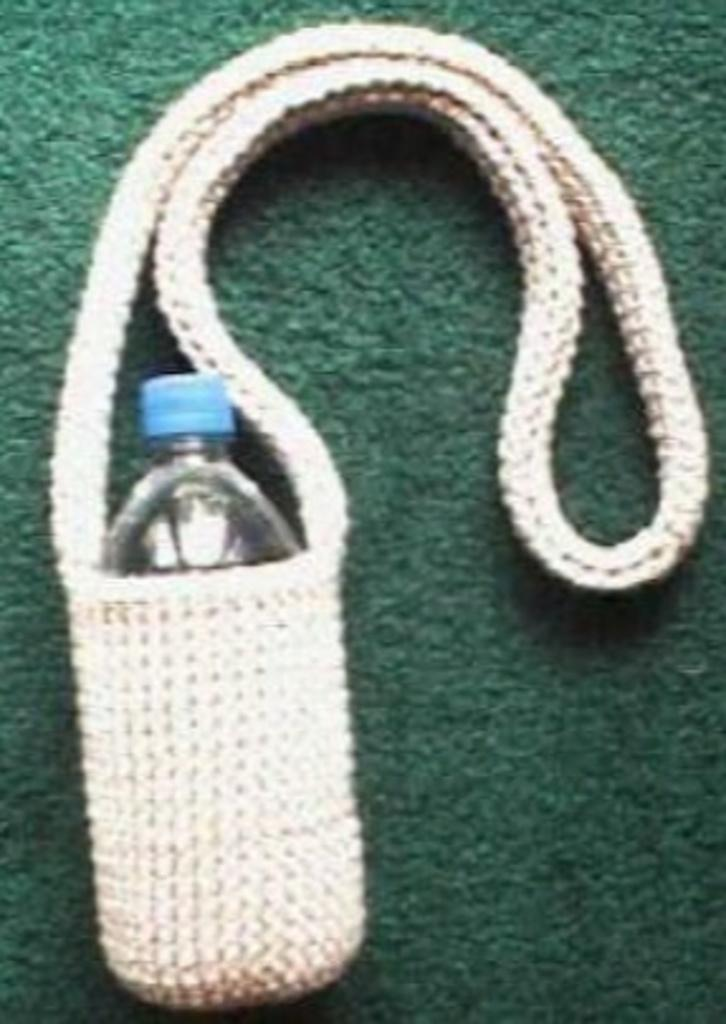What object can be seen in the image? There is a water bottle in the image. Where is the water bottle located? The water bottle is on a couch. What can be seen in the background of the image? The background of the image includes a wall. What color is the wall in the image? The wall is in green color. Are there any toys visible on the couch in the image? There is no mention of toys in the image; only a water bottle is present on the couch. 